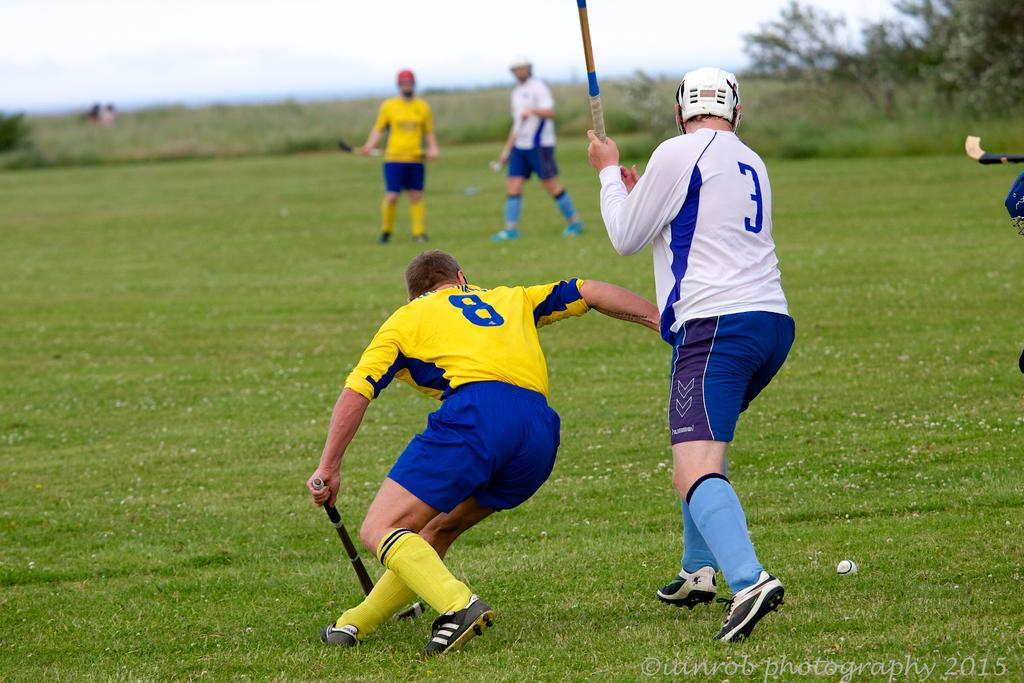<image>
Give a short and clear explanation of the subsequent image. Two teams playing a game on a field and one player has 8 on his jersey. 